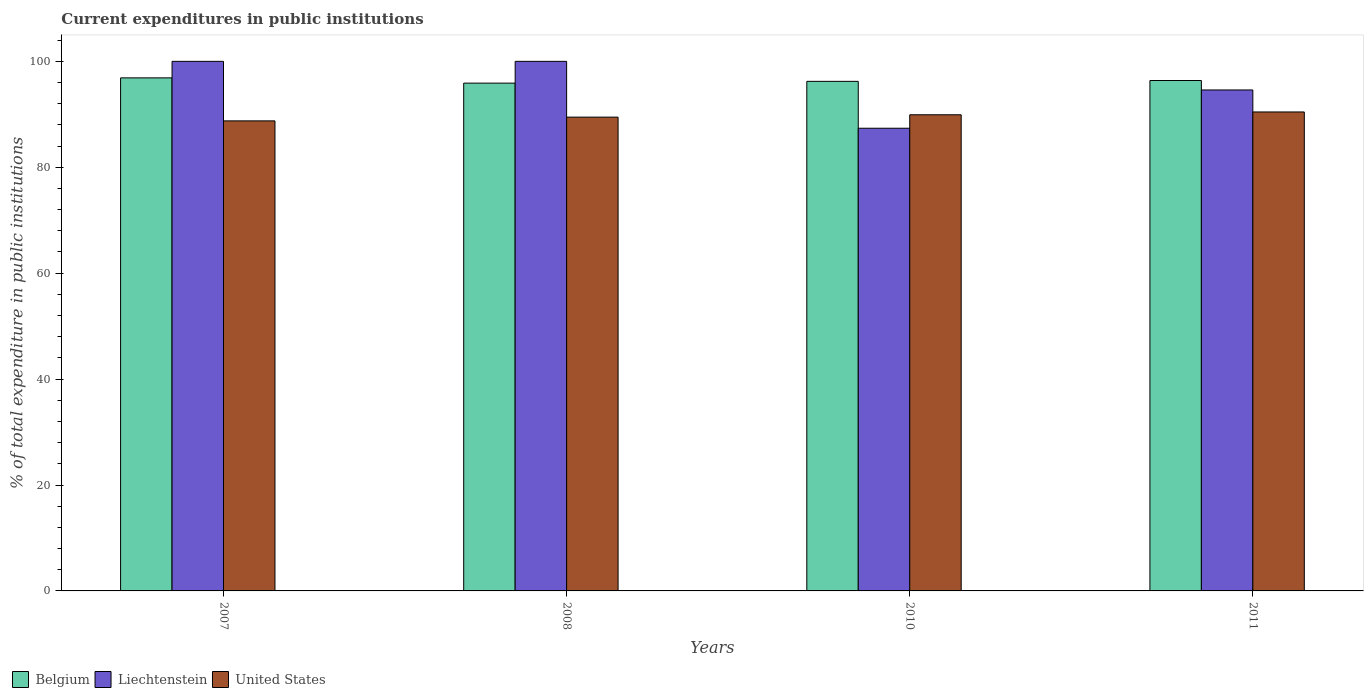Are the number of bars per tick equal to the number of legend labels?
Your answer should be very brief. Yes. How many bars are there on the 4th tick from the left?
Provide a succinct answer. 3. Across all years, what is the maximum current expenditures in public institutions in Belgium?
Offer a terse response. 96.88. Across all years, what is the minimum current expenditures in public institutions in United States?
Ensure brevity in your answer.  88.76. In which year was the current expenditures in public institutions in Liechtenstein maximum?
Make the answer very short. 2007. What is the total current expenditures in public institutions in Belgium in the graph?
Offer a terse response. 385.38. What is the difference between the current expenditures in public institutions in United States in 2008 and that in 2010?
Provide a short and direct response. -0.45. What is the difference between the current expenditures in public institutions in Liechtenstein in 2008 and the current expenditures in public institutions in Belgium in 2010?
Make the answer very short. 3.78. What is the average current expenditures in public institutions in Liechtenstein per year?
Ensure brevity in your answer.  95.49. In the year 2010, what is the difference between the current expenditures in public institutions in Liechtenstein and current expenditures in public institutions in Belgium?
Your answer should be very brief. -8.85. What is the ratio of the current expenditures in public institutions in United States in 2007 to that in 2011?
Keep it short and to the point. 0.98. Is the difference between the current expenditures in public institutions in Liechtenstein in 2008 and 2010 greater than the difference between the current expenditures in public institutions in Belgium in 2008 and 2010?
Offer a terse response. Yes. What is the difference between the highest and the second highest current expenditures in public institutions in Belgium?
Provide a short and direct response. 0.5. What is the difference between the highest and the lowest current expenditures in public institutions in Liechtenstein?
Provide a succinct answer. 12.63. In how many years, is the current expenditures in public institutions in Liechtenstein greater than the average current expenditures in public institutions in Liechtenstein taken over all years?
Ensure brevity in your answer.  2. What does the 2nd bar from the left in 2007 represents?
Provide a succinct answer. Liechtenstein. What does the 2nd bar from the right in 2010 represents?
Ensure brevity in your answer.  Liechtenstein. How many years are there in the graph?
Offer a terse response. 4. What is the difference between two consecutive major ticks on the Y-axis?
Provide a short and direct response. 20. Does the graph contain any zero values?
Your answer should be compact. No. How are the legend labels stacked?
Provide a succinct answer. Horizontal. What is the title of the graph?
Your answer should be very brief. Current expenditures in public institutions. Does "Korea (Republic)" appear as one of the legend labels in the graph?
Your response must be concise. No. What is the label or title of the Y-axis?
Provide a succinct answer. % of total expenditure in public institutions. What is the % of total expenditure in public institutions in Belgium in 2007?
Ensure brevity in your answer.  96.88. What is the % of total expenditure in public institutions of United States in 2007?
Provide a succinct answer. 88.76. What is the % of total expenditure in public institutions in Belgium in 2008?
Offer a terse response. 95.89. What is the % of total expenditure in public institutions of United States in 2008?
Offer a terse response. 89.47. What is the % of total expenditure in public institutions in Belgium in 2010?
Offer a very short reply. 96.22. What is the % of total expenditure in public institutions of Liechtenstein in 2010?
Make the answer very short. 87.37. What is the % of total expenditure in public institutions in United States in 2010?
Keep it short and to the point. 89.91. What is the % of total expenditure in public institutions in Belgium in 2011?
Offer a terse response. 96.38. What is the % of total expenditure in public institutions of Liechtenstein in 2011?
Your response must be concise. 94.6. What is the % of total expenditure in public institutions of United States in 2011?
Your response must be concise. 90.44. Across all years, what is the maximum % of total expenditure in public institutions in Belgium?
Your answer should be very brief. 96.88. Across all years, what is the maximum % of total expenditure in public institutions of United States?
Make the answer very short. 90.44. Across all years, what is the minimum % of total expenditure in public institutions of Belgium?
Give a very brief answer. 95.89. Across all years, what is the minimum % of total expenditure in public institutions in Liechtenstein?
Ensure brevity in your answer.  87.37. Across all years, what is the minimum % of total expenditure in public institutions in United States?
Give a very brief answer. 88.76. What is the total % of total expenditure in public institutions in Belgium in the graph?
Keep it short and to the point. 385.38. What is the total % of total expenditure in public institutions of Liechtenstein in the graph?
Provide a short and direct response. 381.97. What is the total % of total expenditure in public institutions of United States in the graph?
Make the answer very short. 358.58. What is the difference between the % of total expenditure in public institutions in Liechtenstein in 2007 and that in 2008?
Offer a very short reply. 0. What is the difference between the % of total expenditure in public institutions of United States in 2007 and that in 2008?
Offer a terse response. -0.71. What is the difference between the % of total expenditure in public institutions in Belgium in 2007 and that in 2010?
Your answer should be compact. 0.66. What is the difference between the % of total expenditure in public institutions in Liechtenstein in 2007 and that in 2010?
Keep it short and to the point. 12.63. What is the difference between the % of total expenditure in public institutions in United States in 2007 and that in 2010?
Keep it short and to the point. -1.15. What is the difference between the % of total expenditure in public institutions in Belgium in 2007 and that in 2011?
Offer a very short reply. 0.5. What is the difference between the % of total expenditure in public institutions of Liechtenstein in 2007 and that in 2011?
Provide a succinct answer. 5.4. What is the difference between the % of total expenditure in public institutions in United States in 2007 and that in 2011?
Your answer should be compact. -1.69. What is the difference between the % of total expenditure in public institutions in Belgium in 2008 and that in 2010?
Give a very brief answer. -0.33. What is the difference between the % of total expenditure in public institutions in Liechtenstein in 2008 and that in 2010?
Offer a very short reply. 12.63. What is the difference between the % of total expenditure in public institutions of United States in 2008 and that in 2010?
Give a very brief answer. -0.45. What is the difference between the % of total expenditure in public institutions in Belgium in 2008 and that in 2011?
Give a very brief answer. -0.49. What is the difference between the % of total expenditure in public institutions in Liechtenstein in 2008 and that in 2011?
Your response must be concise. 5.4. What is the difference between the % of total expenditure in public institutions of United States in 2008 and that in 2011?
Offer a terse response. -0.98. What is the difference between the % of total expenditure in public institutions in Belgium in 2010 and that in 2011?
Offer a terse response. -0.16. What is the difference between the % of total expenditure in public institutions in Liechtenstein in 2010 and that in 2011?
Offer a terse response. -7.23. What is the difference between the % of total expenditure in public institutions in United States in 2010 and that in 2011?
Give a very brief answer. -0.53. What is the difference between the % of total expenditure in public institutions in Belgium in 2007 and the % of total expenditure in public institutions in Liechtenstein in 2008?
Provide a short and direct response. -3.12. What is the difference between the % of total expenditure in public institutions of Belgium in 2007 and the % of total expenditure in public institutions of United States in 2008?
Provide a short and direct response. 7.42. What is the difference between the % of total expenditure in public institutions of Liechtenstein in 2007 and the % of total expenditure in public institutions of United States in 2008?
Your response must be concise. 10.53. What is the difference between the % of total expenditure in public institutions in Belgium in 2007 and the % of total expenditure in public institutions in Liechtenstein in 2010?
Offer a very short reply. 9.51. What is the difference between the % of total expenditure in public institutions in Belgium in 2007 and the % of total expenditure in public institutions in United States in 2010?
Make the answer very short. 6.97. What is the difference between the % of total expenditure in public institutions of Liechtenstein in 2007 and the % of total expenditure in public institutions of United States in 2010?
Your response must be concise. 10.09. What is the difference between the % of total expenditure in public institutions of Belgium in 2007 and the % of total expenditure in public institutions of Liechtenstein in 2011?
Your answer should be very brief. 2.29. What is the difference between the % of total expenditure in public institutions in Belgium in 2007 and the % of total expenditure in public institutions in United States in 2011?
Offer a very short reply. 6.44. What is the difference between the % of total expenditure in public institutions in Liechtenstein in 2007 and the % of total expenditure in public institutions in United States in 2011?
Make the answer very short. 9.56. What is the difference between the % of total expenditure in public institutions in Belgium in 2008 and the % of total expenditure in public institutions in Liechtenstein in 2010?
Offer a terse response. 8.52. What is the difference between the % of total expenditure in public institutions in Belgium in 2008 and the % of total expenditure in public institutions in United States in 2010?
Give a very brief answer. 5.98. What is the difference between the % of total expenditure in public institutions of Liechtenstein in 2008 and the % of total expenditure in public institutions of United States in 2010?
Keep it short and to the point. 10.09. What is the difference between the % of total expenditure in public institutions of Belgium in 2008 and the % of total expenditure in public institutions of Liechtenstein in 2011?
Offer a terse response. 1.29. What is the difference between the % of total expenditure in public institutions in Belgium in 2008 and the % of total expenditure in public institutions in United States in 2011?
Provide a succinct answer. 5.44. What is the difference between the % of total expenditure in public institutions of Liechtenstein in 2008 and the % of total expenditure in public institutions of United States in 2011?
Give a very brief answer. 9.56. What is the difference between the % of total expenditure in public institutions of Belgium in 2010 and the % of total expenditure in public institutions of Liechtenstein in 2011?
Provide a short and direct response. 1.63. What is the difference between the % of total expenditure in public institutions in Belgium in 2010 and the % of total expenditure in public institutions in United States in 2011?
Ensure brevity in your answer.  5.78. What is the difference between the % of total expenditure in public institutions of Liechtenstein in 2010 and the % of total expenditure in public institutions of United States in 2011?
Your answer should be compact. -3.08. What is the average % of total expenditure in public institutions in Belgium per year?
Offer a terse response. 96.34. What is the average % of total expenditure in public institutions in Liechtenstein per year?
Your answer should be compact. 95.49. What is the average % of total expenditure in public institutions in United States per year?
Your response must be concise. 89.65. In the year 2007, what is the difference between the % of total expenditure in public institutions in Belgium and % of total expenditure in public institutions in Liechtenstein?
Give a very brief answer. -3.12. In the year 2007, what is the difference between the % of total expenditure in public institutions of Belgium and % of total expenditure in public institutions of United States?
Your response must be concise. 8.12. In the year 2007, what is the difference between the % of total expenditure in public institutions of Liechtenstein and % of total expenditure in public institutions of United States?
Your response must be concise. 11.24. In the year 2008, what is the difference between the % of total expenditure in public institutions in Belgium and % of total expenditure in public institutions in Liechtenstein?
Your answer should be compact. -4.11. In the year 2008, what is the difference between the % of total expenditure in public institutions of Belgium and % of total expenditure in public institutions of United States?
Give a very brief answer. 6.42. In the year 2008, what is the difference between the % of total expenditure in public institutions in Liechtenstein and % of total expenditure in public institutions in United States?
Give a very brief answer. 10.53. In the year 2010, what is the difference between the % of total expenditure in public institutions of Belgium and % of total expenditure in public institutions of Liechtenstein?
Provide a succinct answer. 8.85. In the year 2010, what is the difference between the % of total expenditure in public institutions in Belgium and % of total expenditure in public institutions in United States?
Make the answer very short. 6.31. In the year 2010, what is the difference between the % of total expenditure in public institutions in Liechtenstein and % of total expenditure in public institutions in United States?
Provide a short and direct response. -2.54. In the year 2011, what is the difference between the % of total expenditure in public institutions in Belgium and % of total expenditure in public institutions in Liechtenstein?
Offer a terse response. 1.78. In the year 2011, what is the difference between the % of total expenditure in public institutions in Belgium and % of total expenditure in public institutions in United States?
Offer a terse response. 5.94. In the year 2011, what is the difference between the % of total expenditure in public institutions of Liechtenstein and % of total expenditure in public institutions of United States?
Give a very brief answer. 4.15. What is the ratio of the % of total expenditure in public institutions in Belgium in 2007 to that in 2008?
Ensure brevity in your answer.  1.01. What is the ratio of the % of total expenditure in public institutions in Liechtenstein in 2007 to that in 2010?
Ensure brevity in your answer.  1.14. What is the ratio of the % of total expenditure in public institutions in United States in 2007 to that in 2010?
Your answer should be very brief. 0.99. What is the ratio of the % of total expenditure in public institutions in Belgium in 2007 to that in 2011?
Offer a very short reply. 1.01. What is the ratio of the % of total expenditure in public institutions of Liechtenstein in 2007 to that in 2011?
Provide a short and direct response. 1.06. What is the ratio of the % of total expenditure in public institutions in United States in 2007 to that in 2011?
Your answer should be very brief. 0.98. What is the ratio of the % of total expenditure in public institutions in Liechtenstein in 2008 to that in 2010?
Offer a terse response. 1.14. What is the ratio of the % of total expenditure in public institutions of Belgium in 2008 to that in 2011?
Provide a succinct answer. 0.99. What is the ratio of the % of total expenditure in public institutions in Liechtenstein in 2008 to that in 2011?
Your response must be concise. 1.06. What is the ratio of the % of total expenditure in public institutions in Belgium in 2010 to that in 2011?
Ensure brevity in your answer.  1. What is the ratio of the % of total expenditure in public institutions of Liechtenstein in 2010 to that in 2011?
Keep it short and to the point. 0.92. What is the difference between the highest and the second highest % of total expenditure in public institutions in Belgium?
Your answer should be compact. 0.5. What is the difference between the highest and the second highest % of total expenditure in public institutions of Liechtenstein?
Offer a very short reply. 0. What is the difference between the highest and the second highest % of total expenditure in public institutions of United States?
Make the answer very short. 0.53. What is the difference between the highest and the lowest % of total expenditure in public institutions of Belgium?
Your answer should be very brief. 0.99. What is the difference between the highest and the lowest % of total expenditure in public institutions of Liechtenstein?
Make the answer very short. 12.63. What is the difference between the highest and the lowest % of total expenditure in public institutions in United States?
Provide a short and direct response. 1.69. 